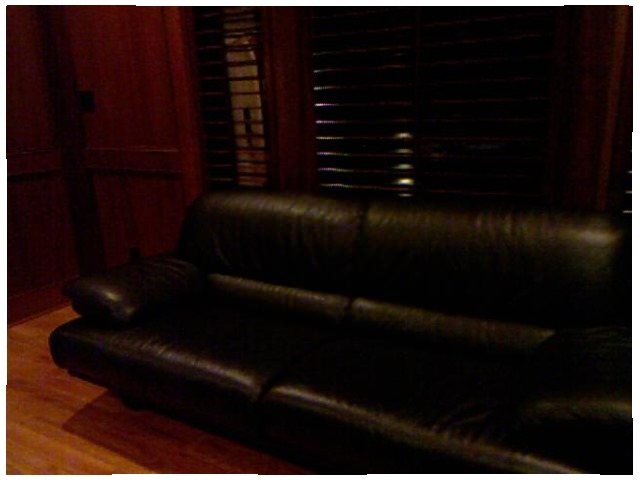<image>
Is the blinds above the floor? Yes. The blinds is positioned above the floor in the vertical space, higher up in the scene. 